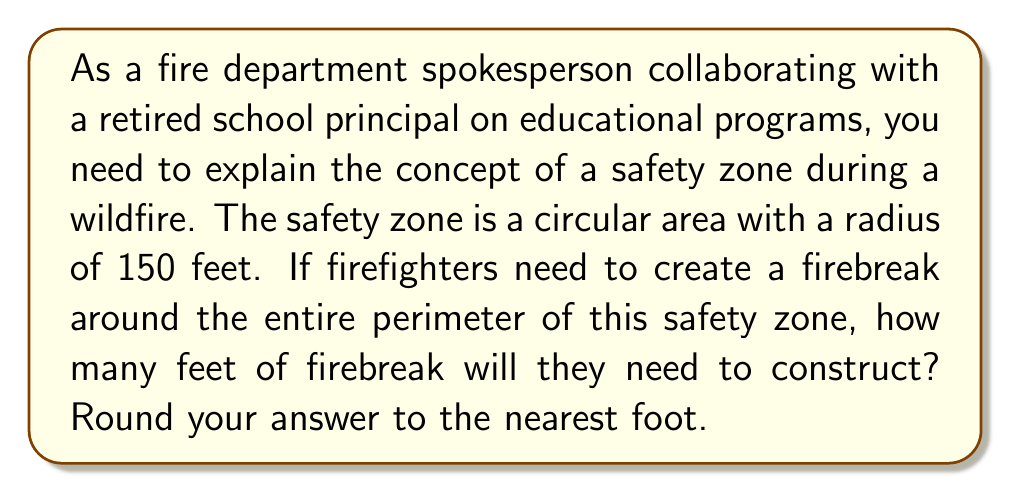Teach me how to tackle this problem. To solve this problem, we need to follow these steps:

1. Identify the shape of the safety zone: It's circular.
2. Recall the formula for the circumference (perimeter) of a circle: $C = 2\pi r$, where $r$ is the radius.
3. Plug in the given radius value and calculate.

Let's proceed with the calculation:

1. The radius of the safety zone is 150 feet.
2. Using the formula $C = 2\pi r$:
   $$C = 2 \pi (150)$$

3. Multiply:
   $$C = 300\pi$$

4. Calculate the value (using $\pi \approx 3.14159$):
   $$C \approx 300 * 3.14159 = 942.477 \text{ feet}$$

5. Rounding to the nearest foot:
   $$C \approx 942 \text{ feet}$$

This means the firefighters will need to construct approximately 942 feet of firebreak around the perimeter of the safety zone.

[asy]
import geometry;

size(200);
draw(circle((0,0),150), red+1);
draw((-170,0)--(170,0), dashed);
draw((0,-170)--(0,170), dashed);
label("150 ft", (75,0), E);
label("Safety Zone", (0,0), fontsize(10));
label("Firebreak", (106,106), NE, fontsize(10));
draw((106,106)--(130,130), Arrow);
[/asy]
Answer: The firefighters will need to construct approximately 942 feet of firebreak. 